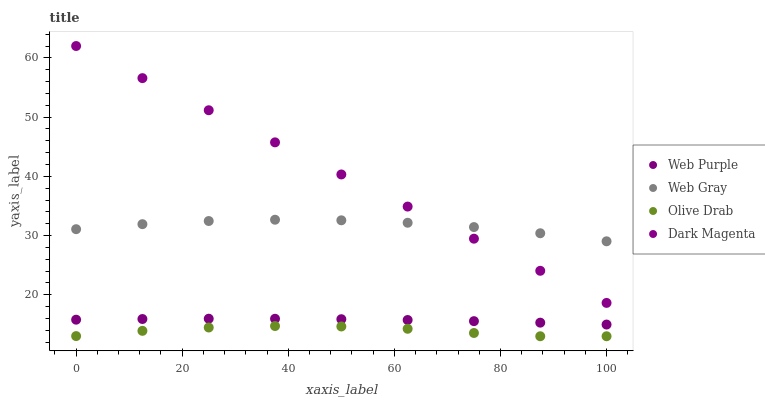Does Olive Drab have the minimum area under the curve?
Answer yes or no. Yes. Does Dark Magenta have the maximum area under the curve?
Answer yes or no. Yes. Does Web Gray have the minimum area under the curve?
Answer yes or no. No. Does Web Gray have the maximum area under the curve?
Answer yes or no. No. Is Dark Magenta the smoothest?
Answer yes or no. Yes. Is Olive Drab the roughest?
Answer yes or no. Yes. Is Web Gray the smoothest?
Answer yes or no. No. Is Web Gray the roughest?
Answer yes or no. No. Does Olive Drab have the lowest value?
Answer yes or no. Yes. Does Dark Magenta have the lowest value?
Answer yes or no. No. Does Dark Magenta have the highest value?
Answer yes or no. Yes. Does Web Gray have the highest value?
Answer yes or no. No. Is Olive Drab less than Web Gray?
Answer yes or no. Yes. Is Web Gray greater than Web Purple?
Answer yes or no. Yes. Does Dark Magenta intersect Web Gray?
Answer yes or no. Yes. Is Dark Magenta less than Web Gray?
Answer yes or no. No. Is Dark Magenta greater than Web Gray?
Answer yes or no. No. Does Olive Drab intersect Web Gray?
Answer yes or no. No. 